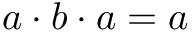Convert formula to latex. <formula><loc_0><loc_0><loc_500><loc_500>a \cdot b \cdot a = a</formula> 